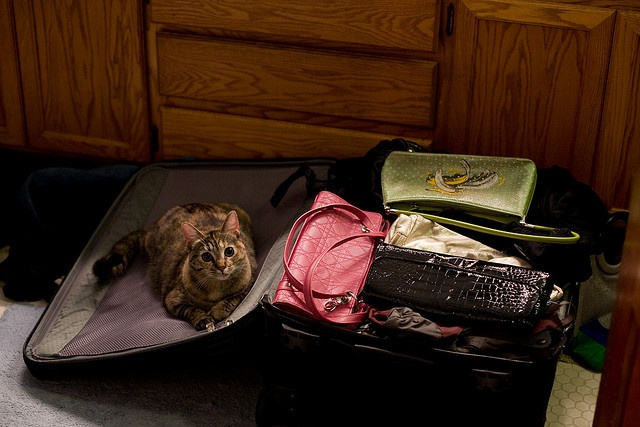Describe the objects in this image and their specific colors. I can see suitcase in maroon, black, gray, and olive tones, cat in maroon, black, and gray tones, handbag in maroon, olive, black, and tan tones, handbag in maroon, salmon, lightpink, and black tones, and handbag in maroon, black, gray, and darkgray tones in this image. 